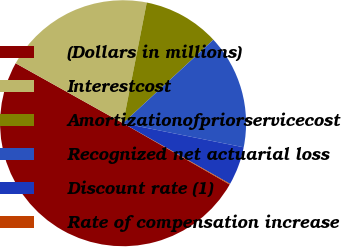Convert chart. <chart><loc_0><loc_0><loc_500><loc_500><pie_chart><fcel>(Dollars in millions)<fcel>Interestcost<fcel>Amortizationofpriorservicecost<fcel>Recognized net actuarial loss<fcel>Discount rate (1)<fcel>Rate of compensation increase<nl><fcel>49.8%<fcel>19.98%<fcel>10.04%<fcel>15.01%<fcel>5.07%<fcel>0.1%<nl></chart> 